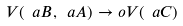Convert formula to latex. <formula><loc_0><loc_0><loc_500><loc_500>V ( \ a B , \ a A ) \to o V ( \ a C )</formula> 